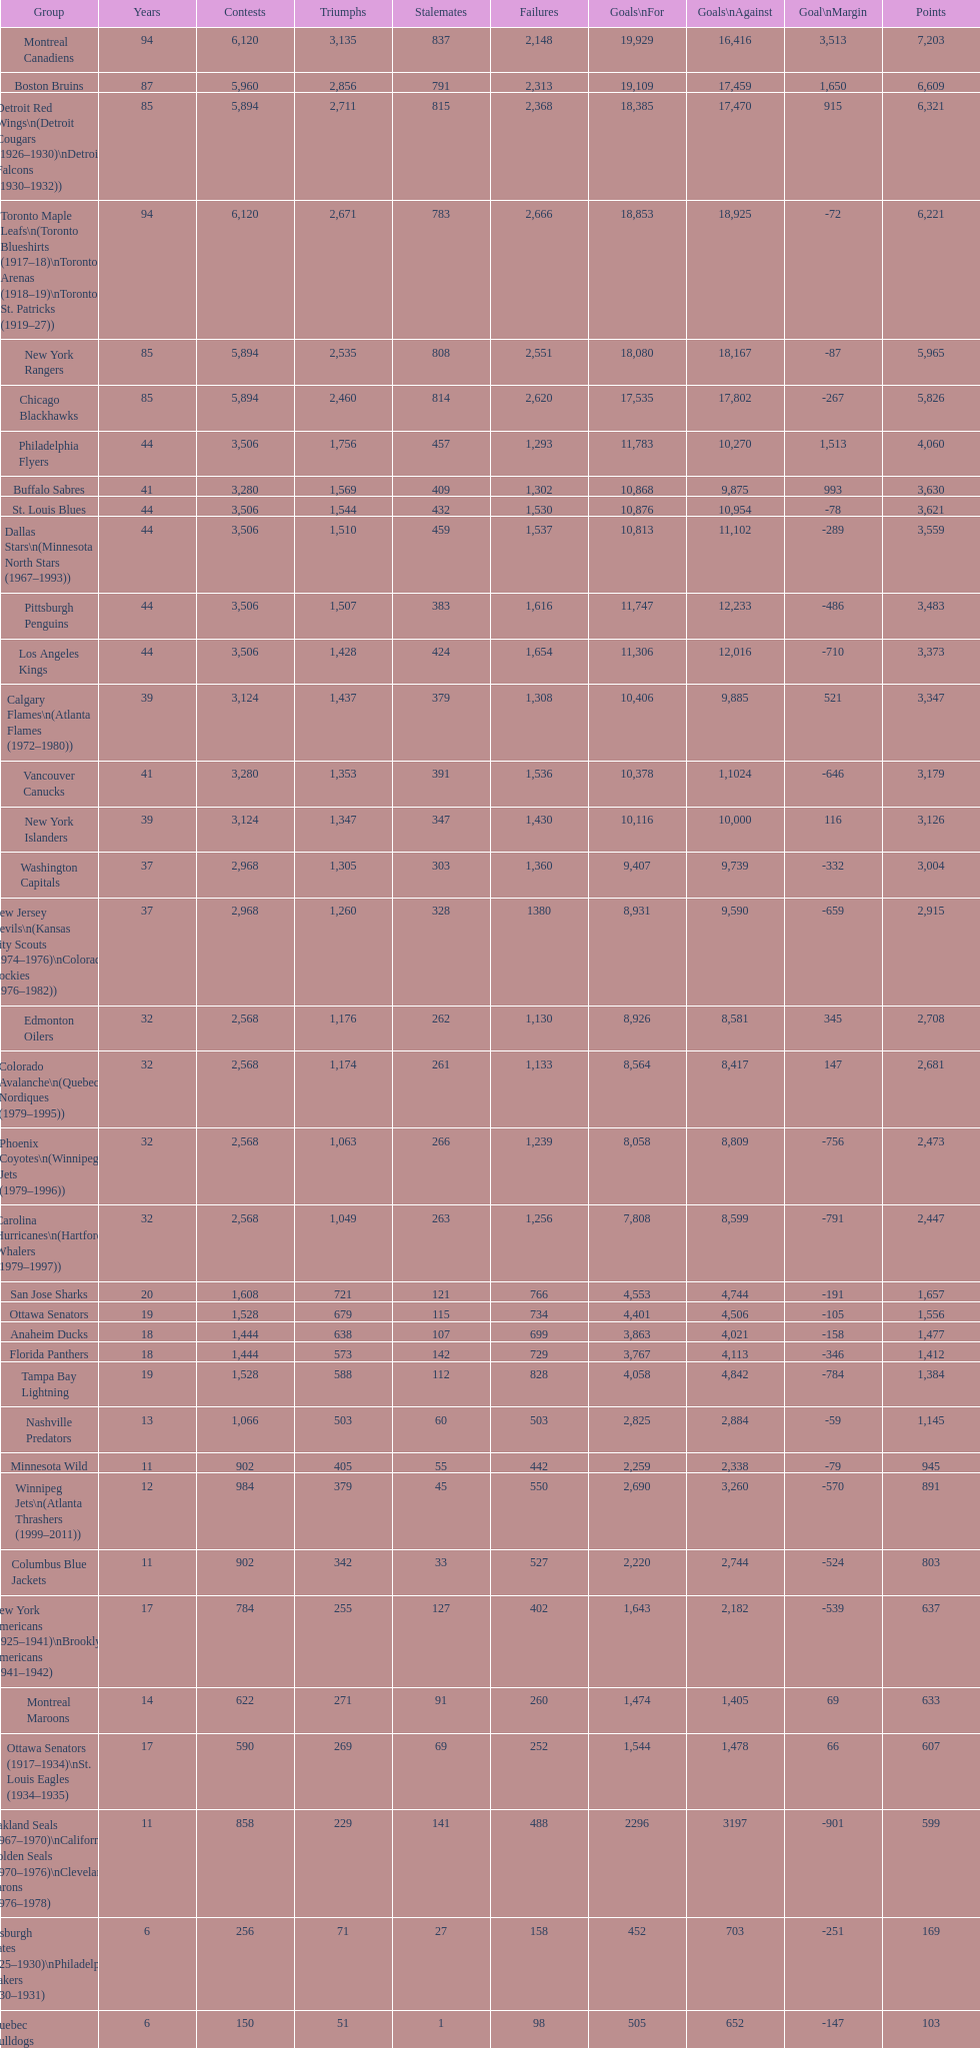Who has the least amount of losses? Montreal Wanderers. 